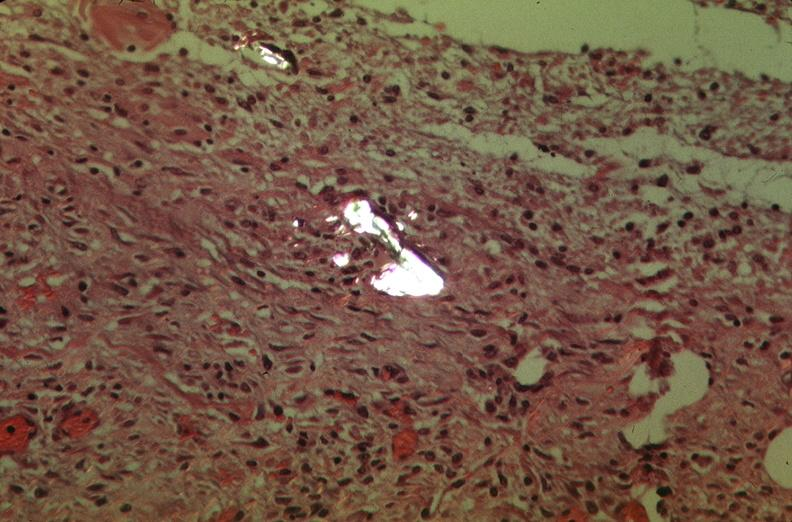what was talc used, alpha-1 antitrypsin deficiency?
Answer the question using a single word or phrase. Used to sclerose emphysematous lung 